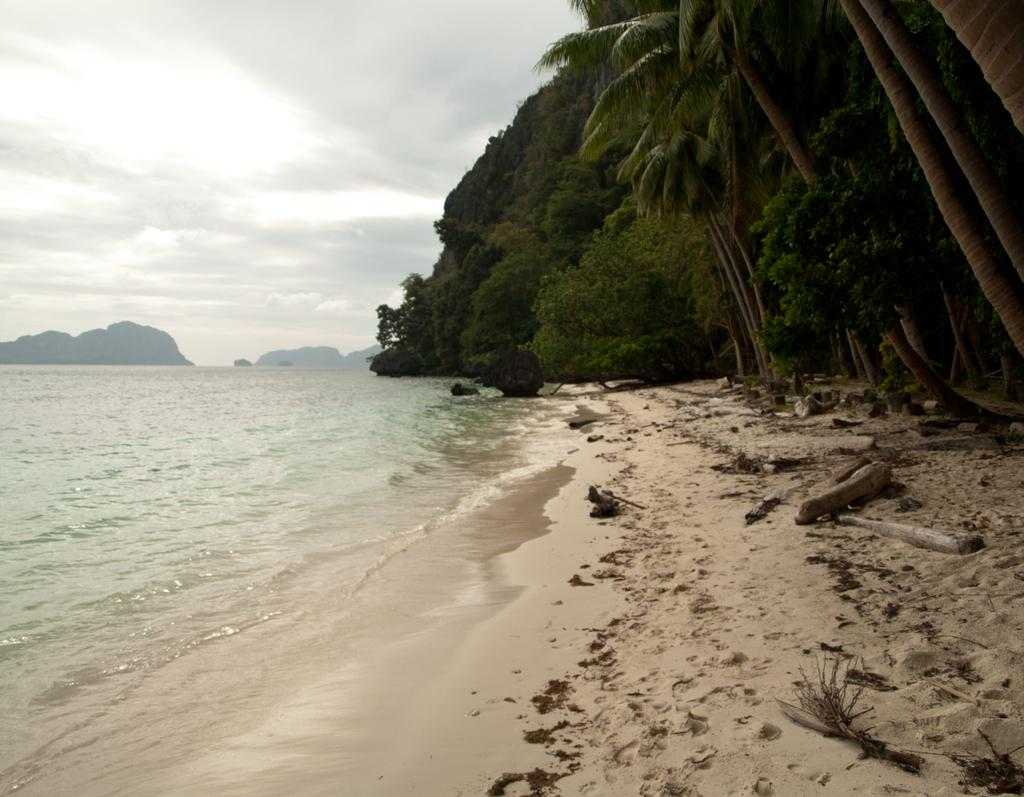What is the main setting of the image? There is a beach in the foreground of the image. What can be seen in the background of the image? There are trees, water, mountains, and the sky visible in the background of the image. What type of natural environment is depicted in the image? The image features a beach, trees, water, mountains, and the sky, which suggests a coastal or mountainous landscape. What type of produce is being harvested in the image? There is no produce or harvesting activity depicted in the image; it features a beach, trees, water, mountains, and the sky. 